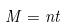<formula> <loc_0><loc_0><loc_500><loc_500>M = n t</formula> 